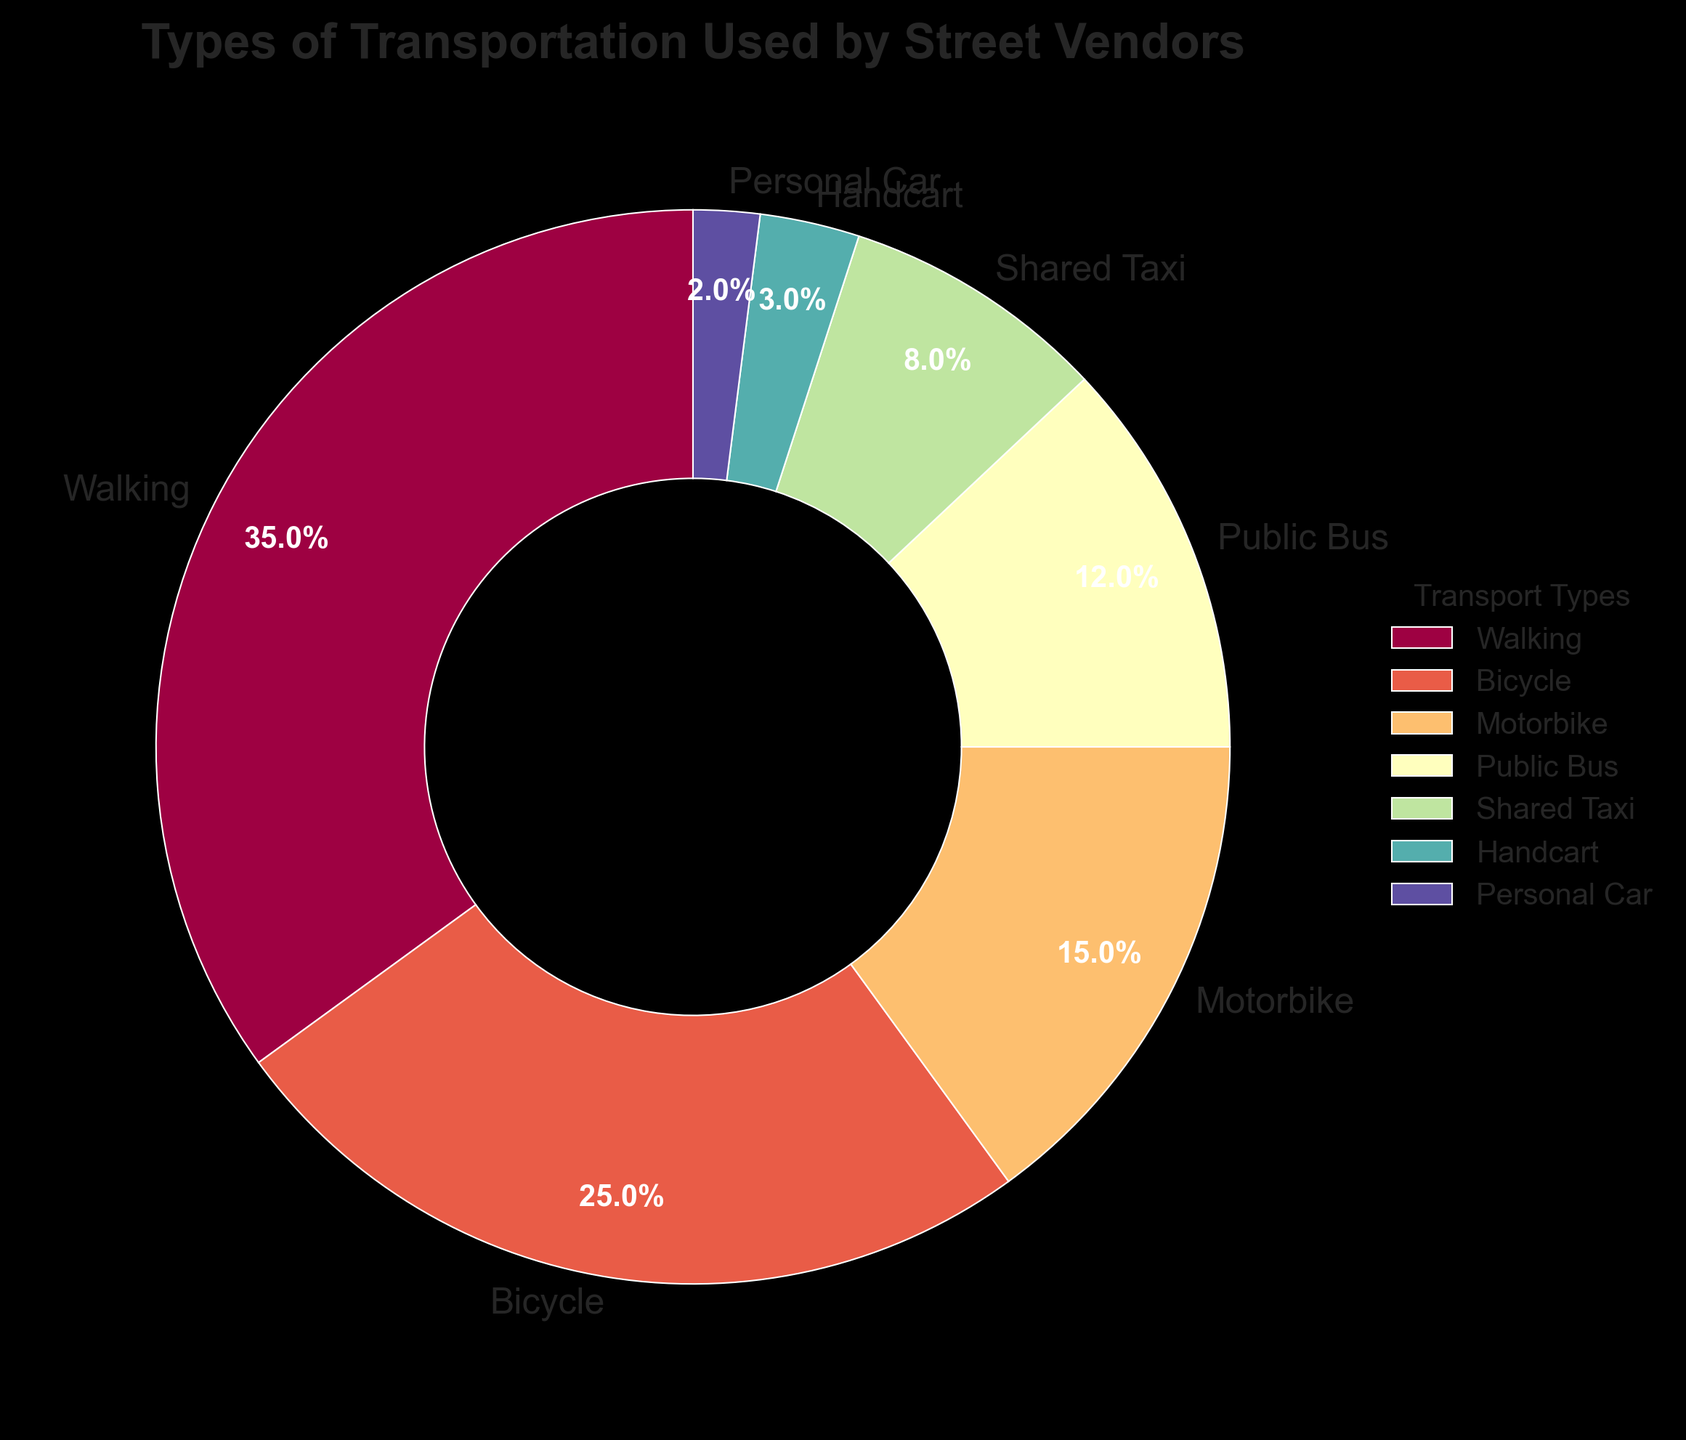What's the most common type of transportation used by street vendors? The pie chart shows the highest percentage for "Walking" at 35%.
Answer: Walking Which two transport types together account for more than half of the transportation methods used? Walking (35%) and Bicycle (25%) together account for 60%, which is more than half.
Answer: Walking and Bicycle How much more common is walking compared to using a personal car? Walking is 35% while using a personal car is 2%. The difference is 35% - 2% = 33%.
Answer: 33% What is the combined percentage of transport types that use a motor vehicle (Motorbike, Public Bus, Shared Taxi, Personal Car)? Motorbike (15%) + Public Bus (12%) + Shared Taxi (8%) + Personal Car (2%) = 37%.
Answer: 37% Which transport type is the least common among street vendors? The pie chart shows the smallest segment for "Personal Car" at 2%.
Answer: Personal Car Is the use of bicycles more common than the combined use of motorbikes and shared taxis? Bicycles are used 25%, while motorbikes (15%) + shared taxis (8%) = 23%. 25% is more than 23%.
Answer: Yes What is the difference in percentage between the use of public buses and shared taxis? Public buses are used 12% and shared taxis 8%, so the difference is 12% - 8% = 4%.
Answer: 4% If the percentages for walking and bicycle are added together, how much larger would that be compared to the percentage for motorbikes? Walking (35%) and Bicycle (25%) add to 60%. Motorbike is 15%. The difference is 60% - 15% = 45%.
Answer: 45% Which transport mode is represented by the segment that appears to be approximately one-third of the pie chart? The segment representing "Walking" is approximately one-third of the pie chart at 35%.
Answer: Walking 